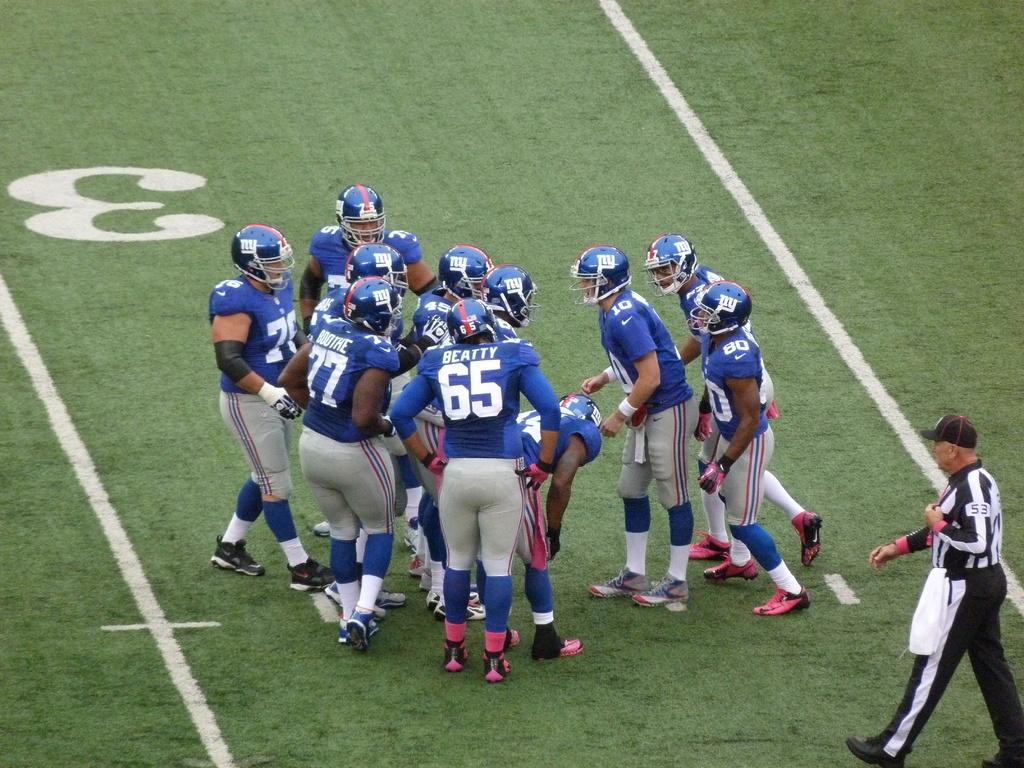What are the persons wearing on their heads in the image? The persons are wearing helmets in the image. Where are the persons wearing helmets located? They are visible on the ground in the image. What is the person on the right side of the image wearing? The person on the right side of the image is wearing a blue color dress. What is the person on the right side of the image doing? The person is walking towards the ground on the right side of the image. How many friends are visible in the image? There is no mention of friends in the image; it only shows persons wearing helmets and a person in a blue dress. 